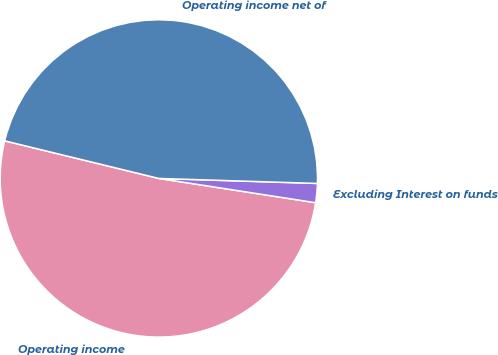Convert chart to OTSL. <chart><loc_0><loc_0><loc_500><loc_500><pie_chart><fcel>Operating income<fcel>Excluding Interest on funds<fcel>Operating income net of<nl><fcel>51.36%<fcel>1.94%<fcel>46.69%<nl></chart> 